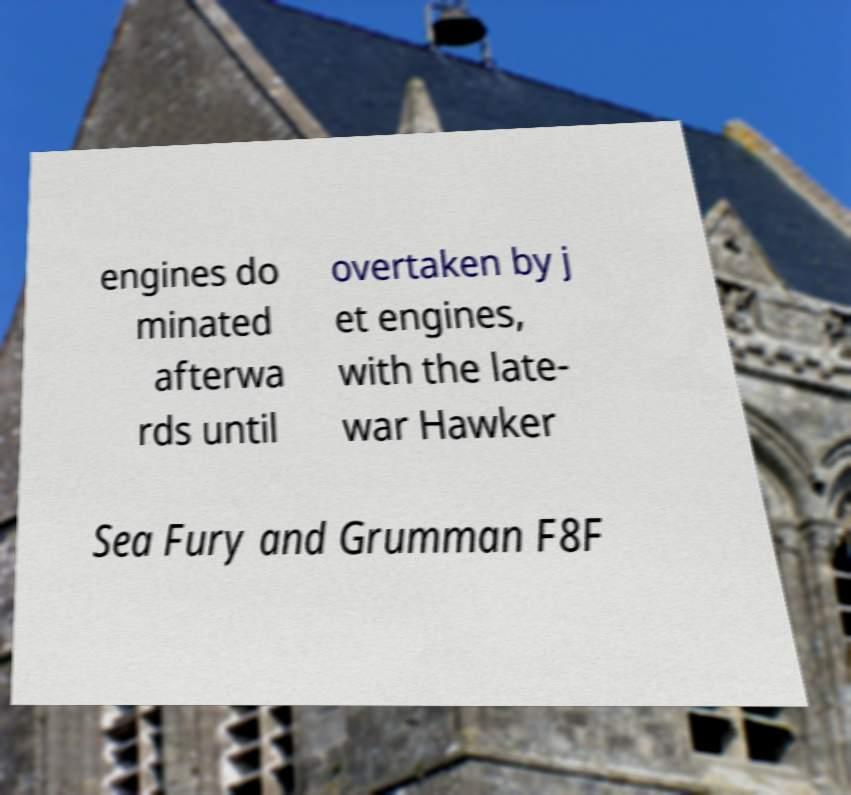I need the written content from this picture converted into text. Can you do that? engines do minated afterwa rds until overtaken by j et engines, with the late- war Hawker Sea Fury and Grumman F8F 